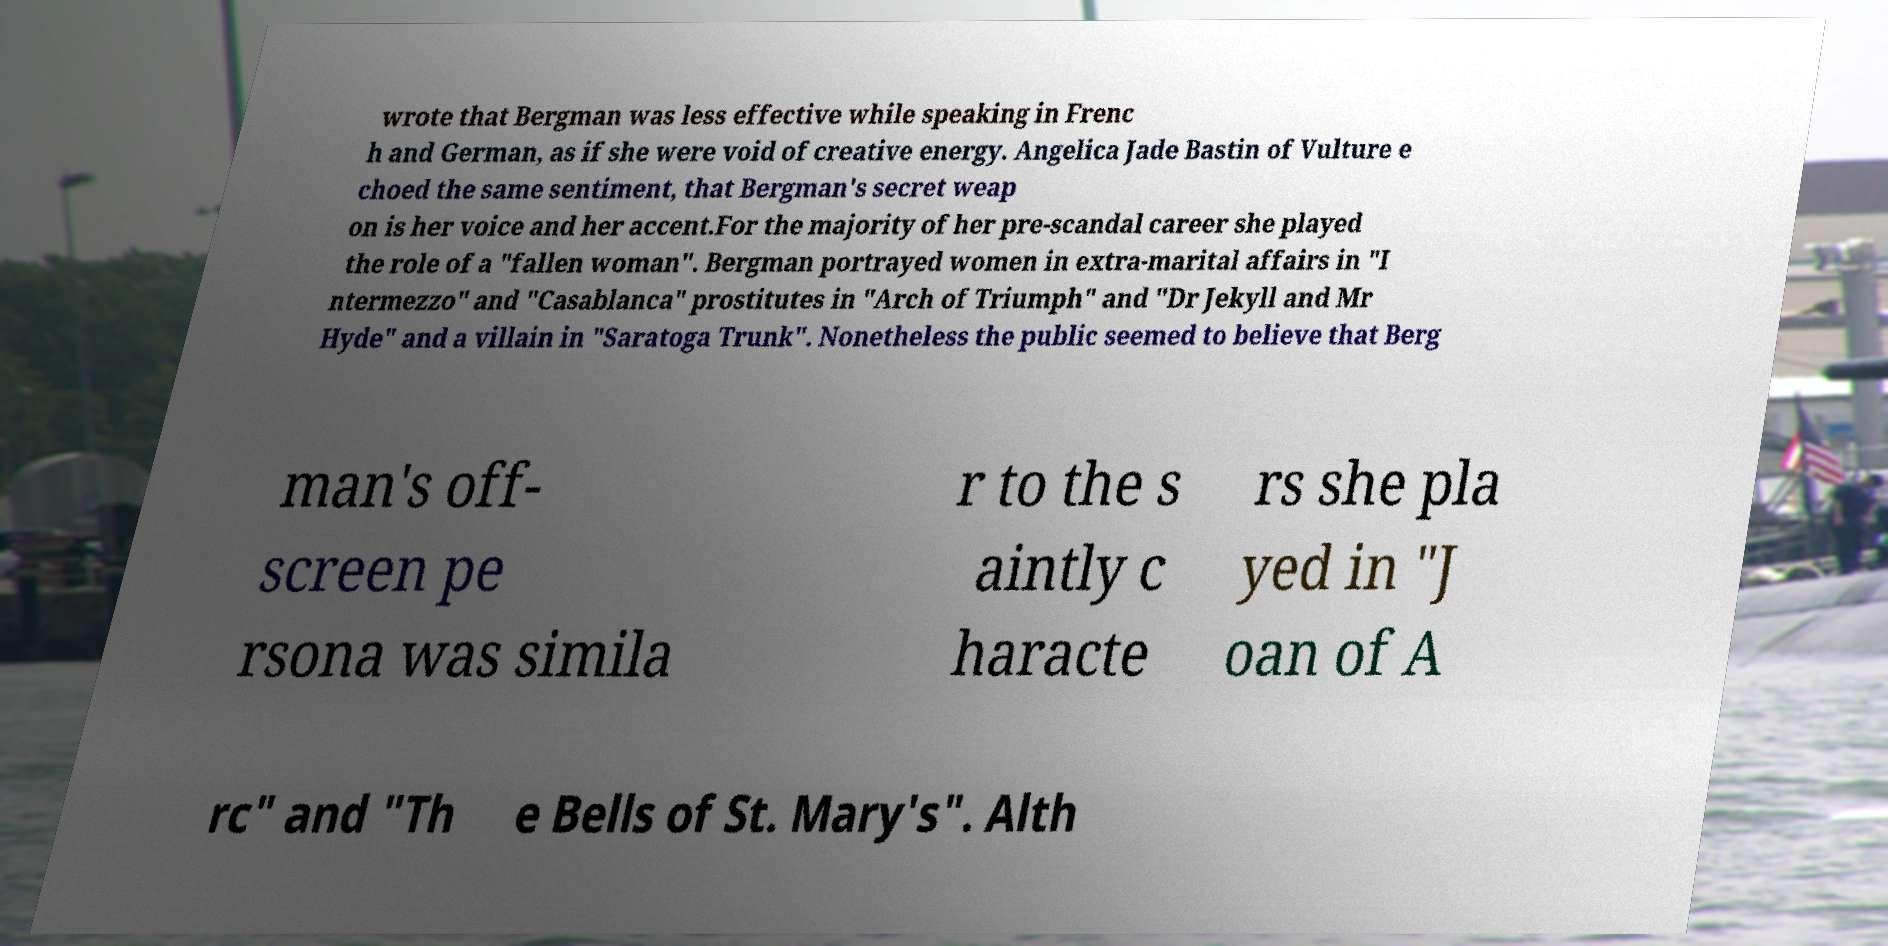Can you accurately transcribe the text from the provided image for me? wrote that Bergman was less effective while speaking in Frenc h and German, as if she were void of creative energy. Angelica Jade Bastin of Vulture e choed the same sentiment, that Bergman's secret weap on is her voice and her accent.For the majority of her pre-scandal career she played the role of a "fallen woman". Bergman portrayed women in extra-marital affairs in "I ntermezzo" and "Casablanca" prostitutes in "Arch of Triumph" and "Dr Jekyll and Mr Hyde" and a villain in "Saratoga Trunk". Nonetheless the public seemed to believe that Berg man's off- screen pe rsona was simila r to the s aintly c haracte rs she pla yed in "J oan of A rc" and "Th e Bells of St. Mary's". Alth 